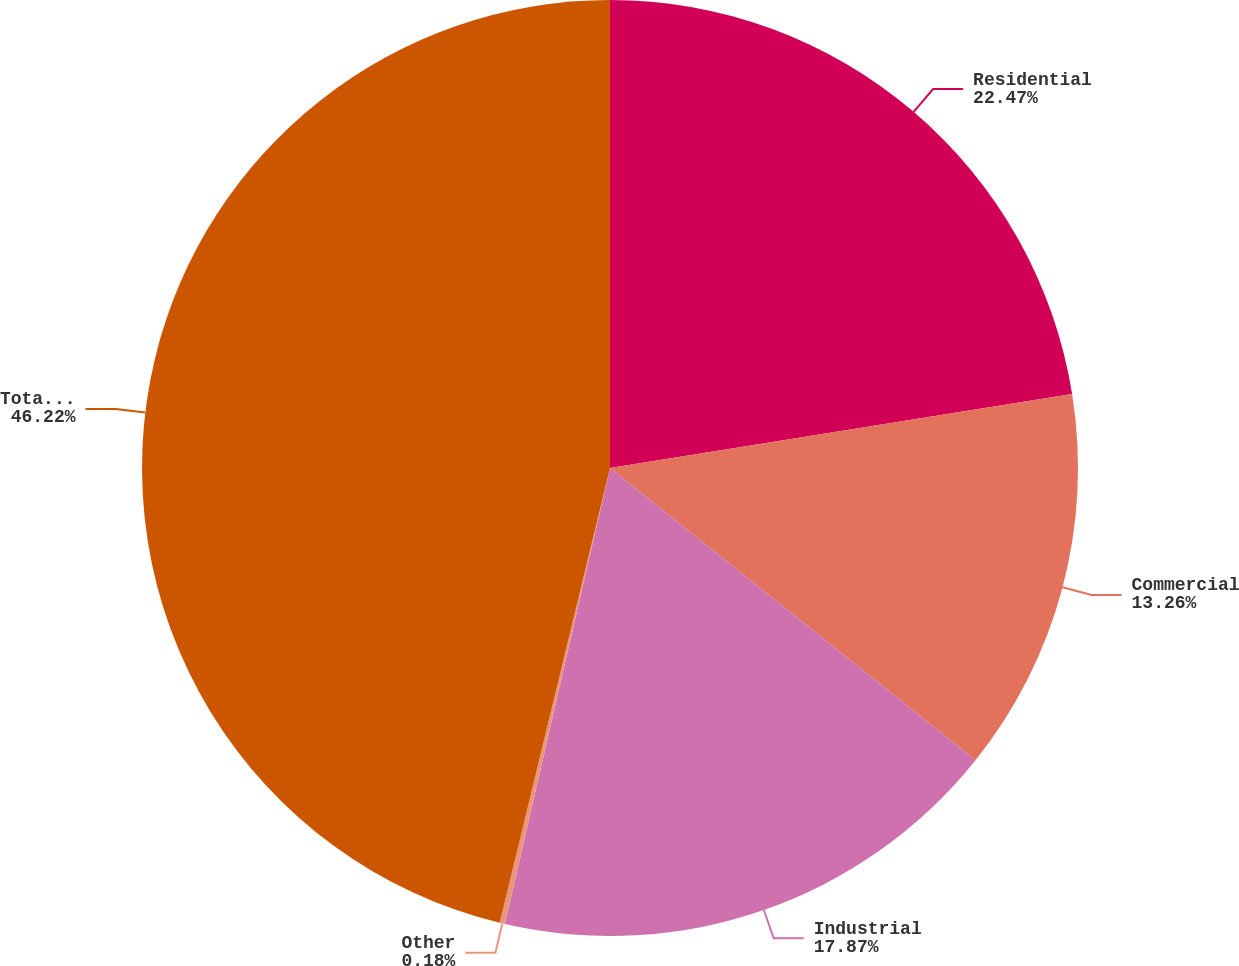Convert chart to OTSL. <chart><loc_0><loc_0><loc_500><loc_500><pie_chart><fcel>Residential<fcel>Commercial<fcel>Industrial<fcel>Other<fcel>Total Electric Distribution<nl><fcel>22.47%<fcel>13.26%<fcel>17.87%<fcel>0.18%<fcel>46.21%<nl></chart> 